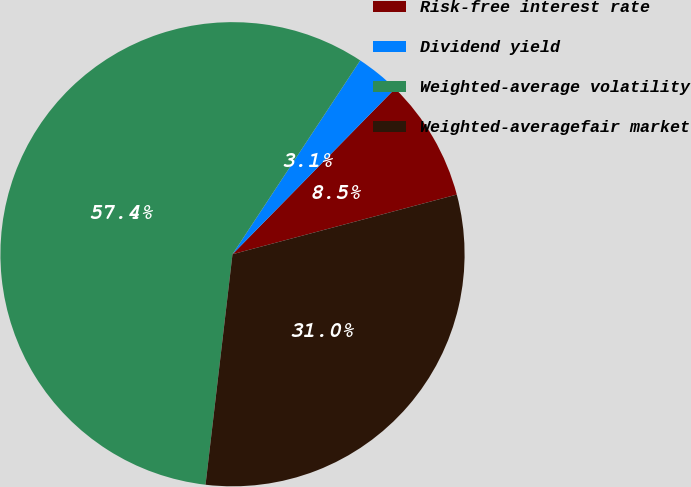Convert chart. <chart><loc_0><loc_0><loc_500><loc_500><pie_chart><fcel>Risk-free interest rate<fcel>Dividend yield<fcel>Weighted-average volatility<fcel>Weighted-averagefair market<nl><fcel>8.51%<fcel>3.08%<fcel>57.42%<fcel>30.99%<nl></chart> 